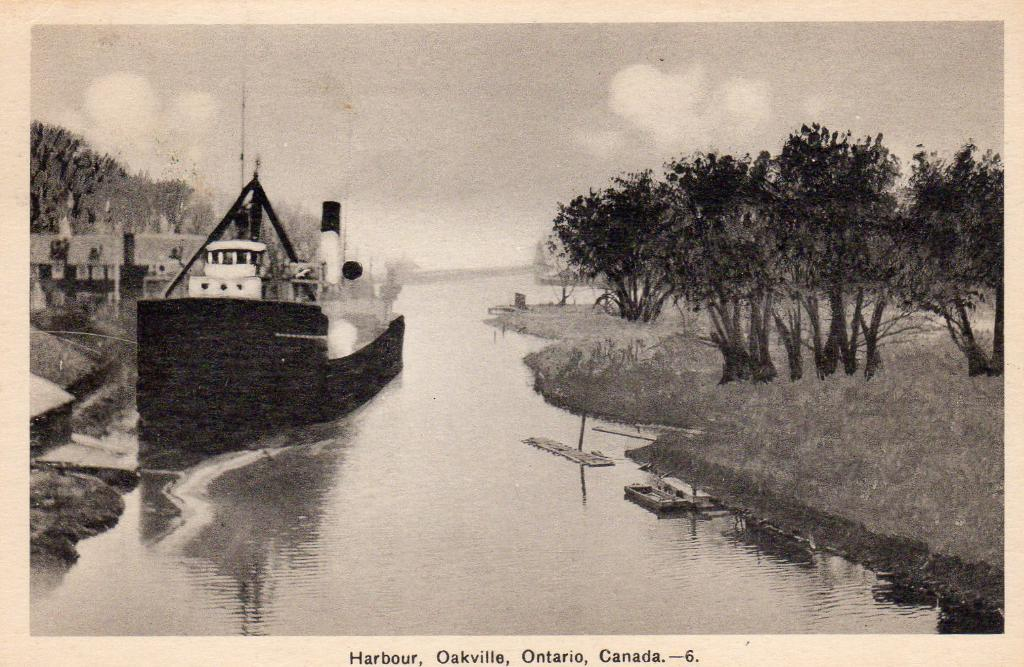<image>
Provide a brief description of the given image. Postcard showing a boat by a body of a body of river in Ontario, Canada. 